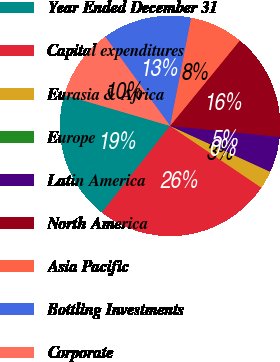Convert chart. <chart><loc_0><loc_0><loc_500><loc_500><pie_chart><fcel>Year Ended December 31<fcel>Capital expenditures<fcel>Eurasia & Africa<fcel>Europe<fcel>Latin America<fcel>North America<fcel>Asia Pacific<fcel>Bottling Investments<fcel>Corporate<nl><fcel>18.92%<fcel>26.14%<fcel>2.62%<fcel>0.01%<fcel>5.24%<fcel>15.69%<fcel>7.85%<fcel>13.07%<fcel>10.46%<nl></chart> 